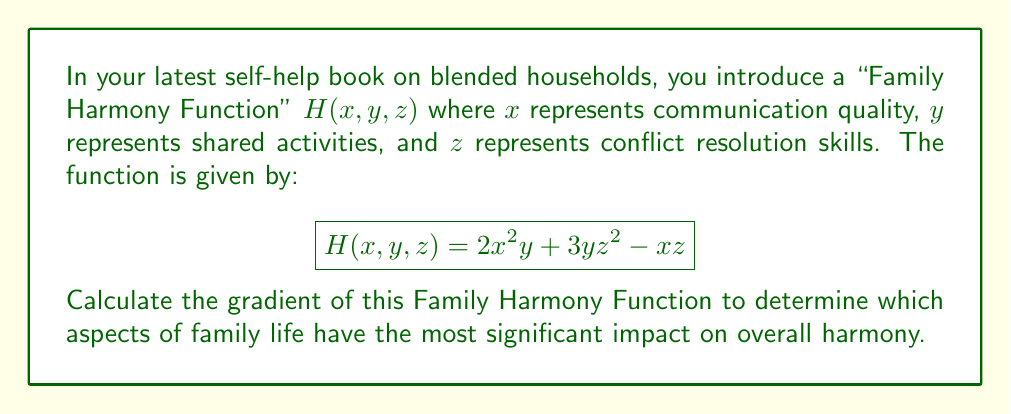Solve this math problem. To calculate the gradient of the Family Harmony Function, we need to find the partial derivatives with respect to each variable (x, y, and z). The gradient is a vector of these partial derivatives.

1. Calculate $\frac{\partial H}{\partial x}$:
   $$\frac{\partial H}{\partial x} = \frac{\partial}{\partial x}(2x^2y + 3yz^2 - xz) = 4xy - z$$

2. Calculate $\frac{\partial H}{\partial y}$:
   $$\frac{\partial H}{\partial y} = \frac{\partial}{\partial y}(2x^2y + 3yz^2 - xz) = 2x^2 + 3z^2$$

3. Calculate $\frac{\partial H}{\partial z}$:
   $$\frac{\partial H}{\partial z} = \frac{\partial}{\partial z}(2x^2y + 3yz^2 - xz) = 6yz - x$$

4. Combine the partial derivatives into the gradient vector:
   $$\nabla H(x, y, z) = \left(\frac{\partial H}{\partial x}, \frac{\partial H}{\partial y}, \frac{\partial H}{\partial z}\right)$$

5. Substitute the calculated partial derivatives:
   $$\nabla H(x, y, z) = (4xy - z, 2x^2 + 3z^2, 6yz - x)$$

This gradient vector shows how changes in each variable (communication, shared activities, and conflict resolution) affect the overall family harmony.
Answer: $\nabla H(x, y, z) = (4xy - z, 2x^2 + 3z^2, 6yz - x)$ 